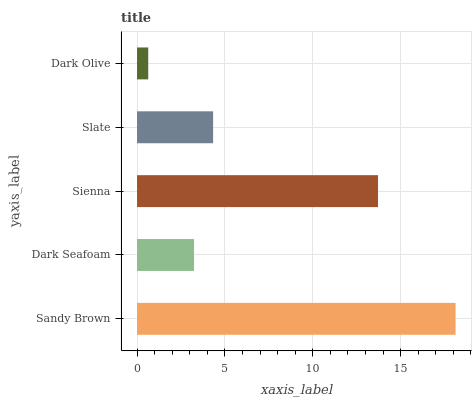Is Dark Olive the minimum?
Answer yes or no. Yes. Is Sandy Brown the maximum?
Answer yes or no. Yes. Is Dark Seafoam the minimum?
Answer yes or no. No. Is Dark Seafoam the maximum?
Answer yes or no. No. Is Sandy Brown greater than Dark Seafoam?
Answer yes or no. Yes. Is Dark Seafoam less than Sandy Brown?
Answer yes or no. Yes. Is Dark Seafoam greater than Sandy Brown?
Answer yes or no. No. Is Sandy Brown less than Dark Seafoam?
Answer yes or no. No. Is Slate the high median?
Answer yes or no. Yes. Is Slate the low median?
Answer yes or no. Yes. Is Dark Seafoam the high median?
Answer yes or no. No. Is Dark Seafoam the low median?
Answer yes or no. No. 